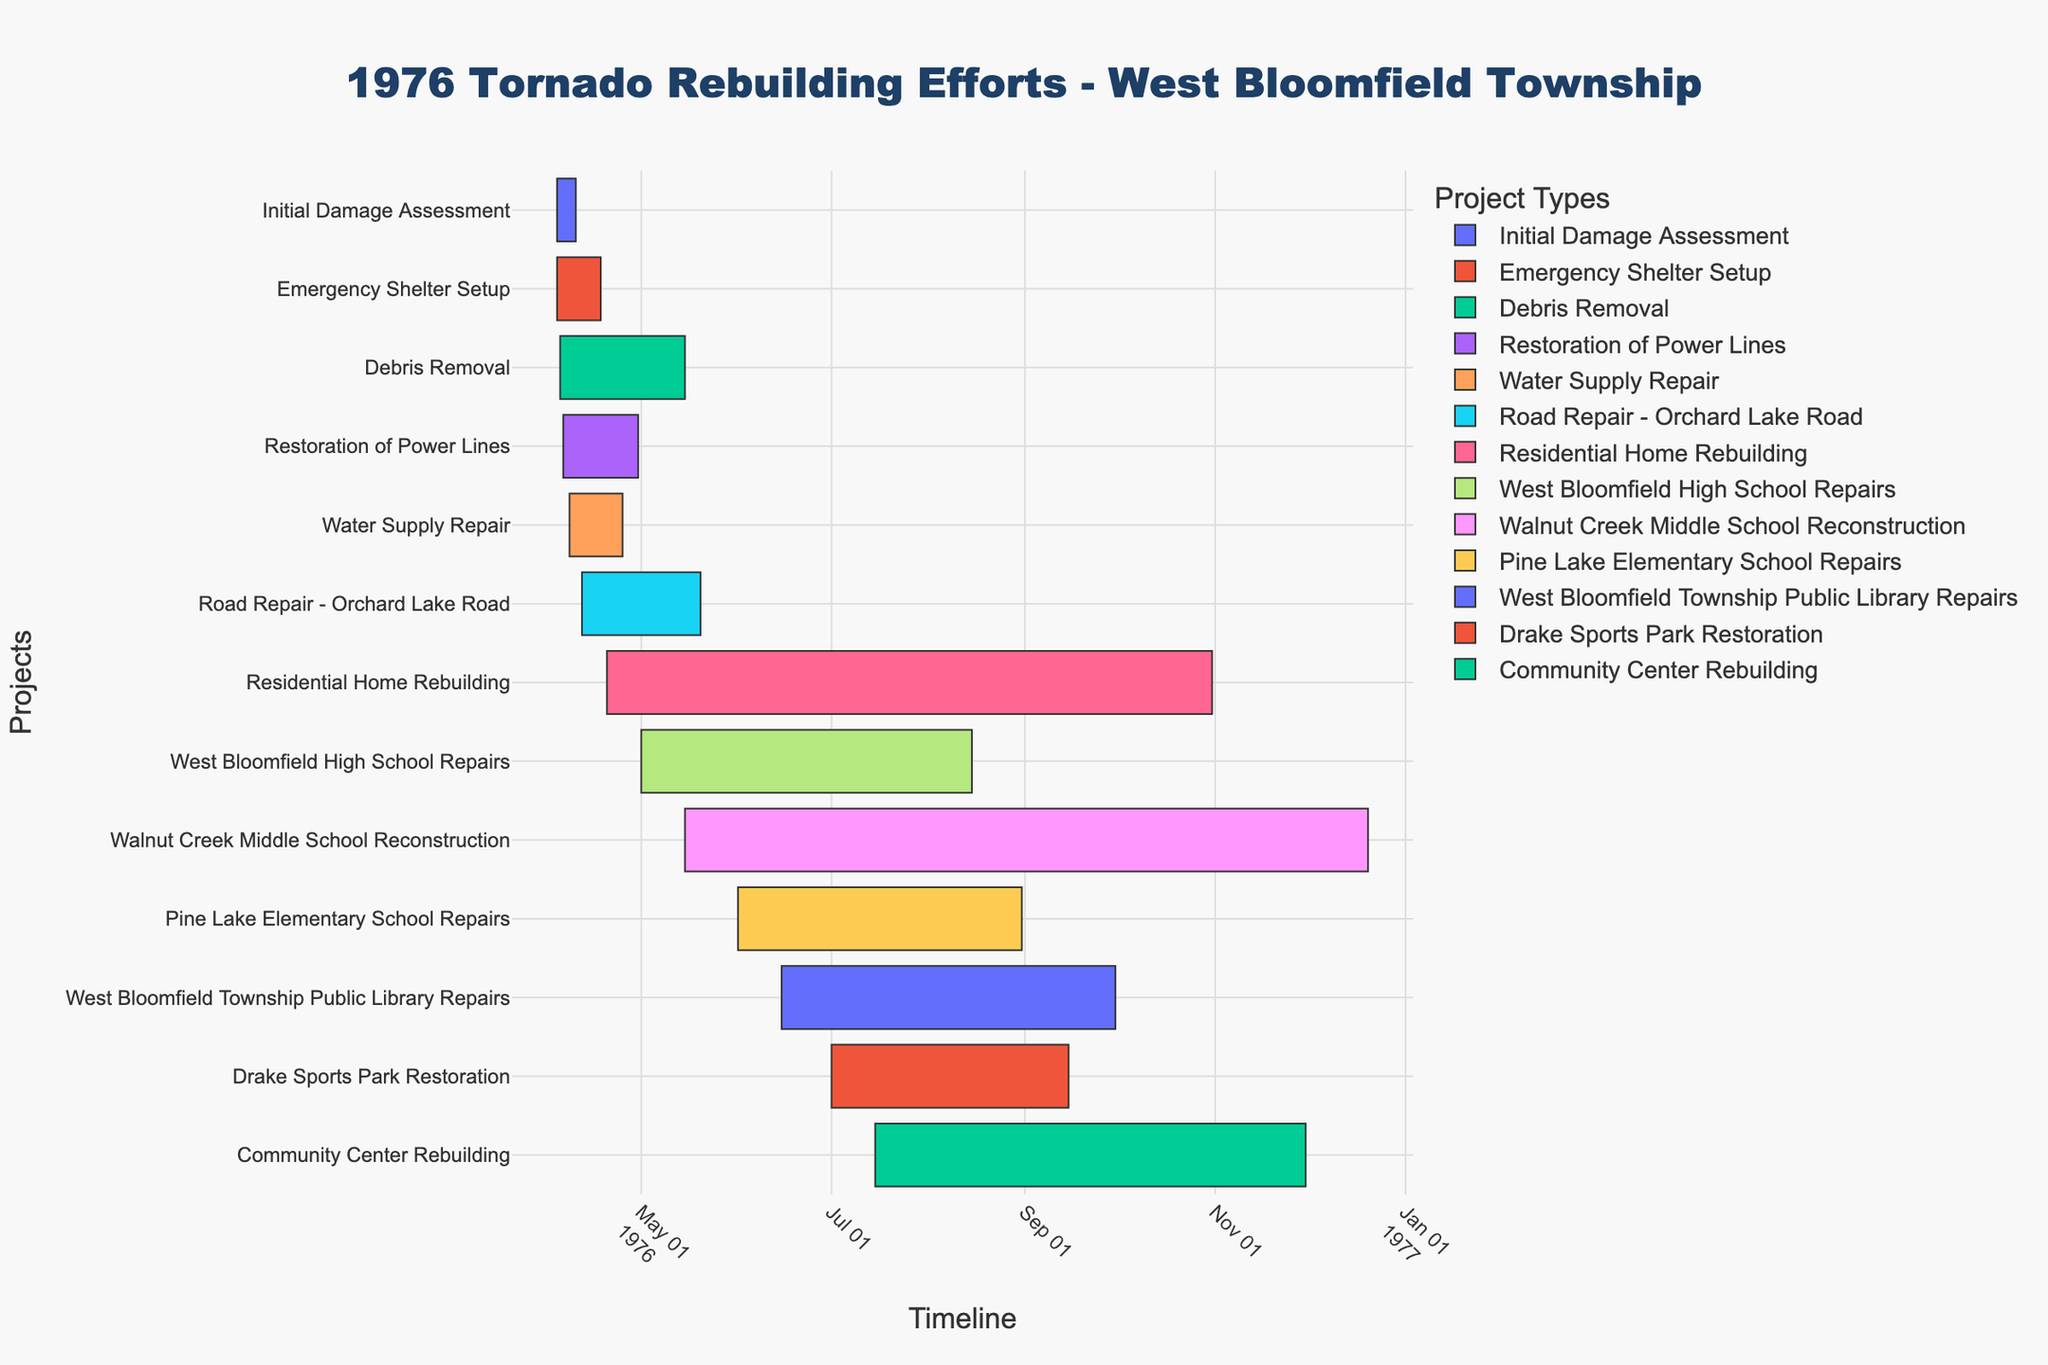What's the title of the figure? The title of the figure is usually displayed at the top. In this case, it reads "1976 Tornado Rebuilding Efforts - West Bloomfield Township".
Answer: 1976 Tornado Rebuilding Efforts - West Bloomfield Township Which task has the longest duration? The duration of each task can be identified by looking at the length of their respective bars. To find the longest task, compare the lengths of all bars. "Residential Home Rebuilding" has the longest bar extending from April 20, 1976, to October 31, 1976.
Answer: Residential Home Rebuilding How long did the Emergency Shelter Setup take? The start and end dates for the "Emergency Shelter Setup" task are from April 4, 1976, to April 18, 1976, respectively. The duration can be calculated by subtracting the start date from the end date. (April 18, 1976 - April 4, 1976) = 14 days.
Answer: 14 days Which tasks were completed within the first two months (April to May 1976)? Identify tasks with end dates on or before May 31, 1976. The tasks meeting this criterion are "Initial Damage Assessment," "Emergency Shelter Setup," "Debris Removal," "Restoration of Power Lines," and "Water Supply Repair".
Answer: Initial Damage Assessment, Emergency Shelter Setup, Debris Removal, Restoration of Power Lines, Water Supply Repair Which school's reconstruction took the longest time? Compare the durations of repairs and reconstructions for West Bloomfield High School, Walnut Creek Middle School, and Pine Lake Elementary School by looking at the lengths of their respective bars. "Walnut Creek Middle School Reconstruction" took the longest time from May 15, 1976, to December 20, 1976.
Answer: Walnut Creek Middle School Did Debris Removal start before Water Supply Repair? Check the start dates of "Debris Removal" and "Water Supply Repair". "Debris Removal" started on April 5, 1976, and "Water Supply Repair" started on April 8, 1976. Thus, "Debris Removal" started earlier.
Answer: Yes Which task ended last? The task with the latest end date will be the last one to finish. "Walnut Creek Middle School Reconstruction" ended on December 20, 1976, which is the latest.
Answer: Walnut Creek Middle School Reconstruction What is the total time taken for the Public Library Repairs? Check the start and end dates for "West Bloomfield Township Public Library Repairs". The task started on June 15, 1976, and ended on September 30, 1976. Calculate the difference. (September 30, 1976 - June 15, 1976) = 107 days.
Answer: 107 days Did the Community Center Rebuilding start before or after the Pine Lake Elementary School Repairs? Compare their start dates. "Community Center Rebuilding" started on July 15, 1976, and "Pine Lake Elementary School Repairs" started on June 1, 1976. Therefore, the Community Center Rebuilding started after Pine Lake Elementary School Repairs.
Answer: After How many tasks were actively worked on in May 1976? Identify tasks that overlap with May 1976 by checking if they were ongoing in that month. The tasks are "Debris Removal," "Restoration of Power Lines," "Water Supply Repair," "Road Repair - Orchard Lake Road," "Residential Home Rebuilding," and "West Bloomfield High School Repairs." There are six tasks.
Answer: Six tasks 